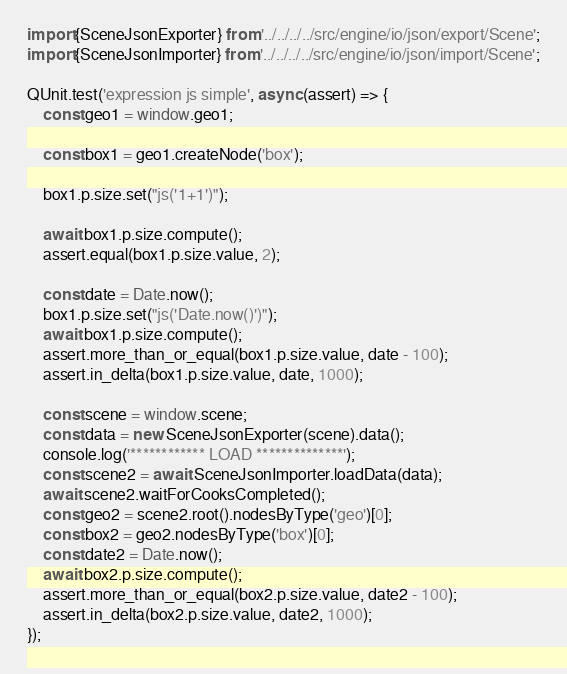<code> <loc_0><loc_0><loc_500><loc_500><_TypeScript_>import {SceneJsonExporter} from '../../../../src/engine/io/json/export/Scene';
import {SceneJsonImporter} from '../../../../src/engine/io/json/import/Scene';

QUnit.test('expression js simple', async (assert) => {
	const geo1 = window.geo1;

	const box1 = geo1.createNode('box');

	box1.p.size.set("js('1+1')");

	await box1.p.size.compute();
	assert.equal(box1.p.size.value, 2);

	const date = Date.now();
	box1.p.size.set("js('Date.now()')");
	await box1.p.size.compute();
	assert.more_than_or_equal(box1.p.size.value, date - 100);
	assert.in_delta(box1.p.size.value, date, 1000);

	const scene = window.scene;
	const data = new SceneJsonExporter(scene).data();
	console.log('************ LOAD **************');
	const scene2 = await SceneJsonImporter.loadData(data);
	await scene2.waitForCooksCompleted();
	const geo2 = scene2.root().nodesByType('geo')[0];
	const box2 = geo2.nodesByType('box')[0];
	const date2 = Date.now();
	await box2.p.size.compute();
	assert.more_than_or_equal(box2.p.size.value, date2 - 100);
	assert.in_delta(box2.p.size.value, date2, 1000);
});
</code> 